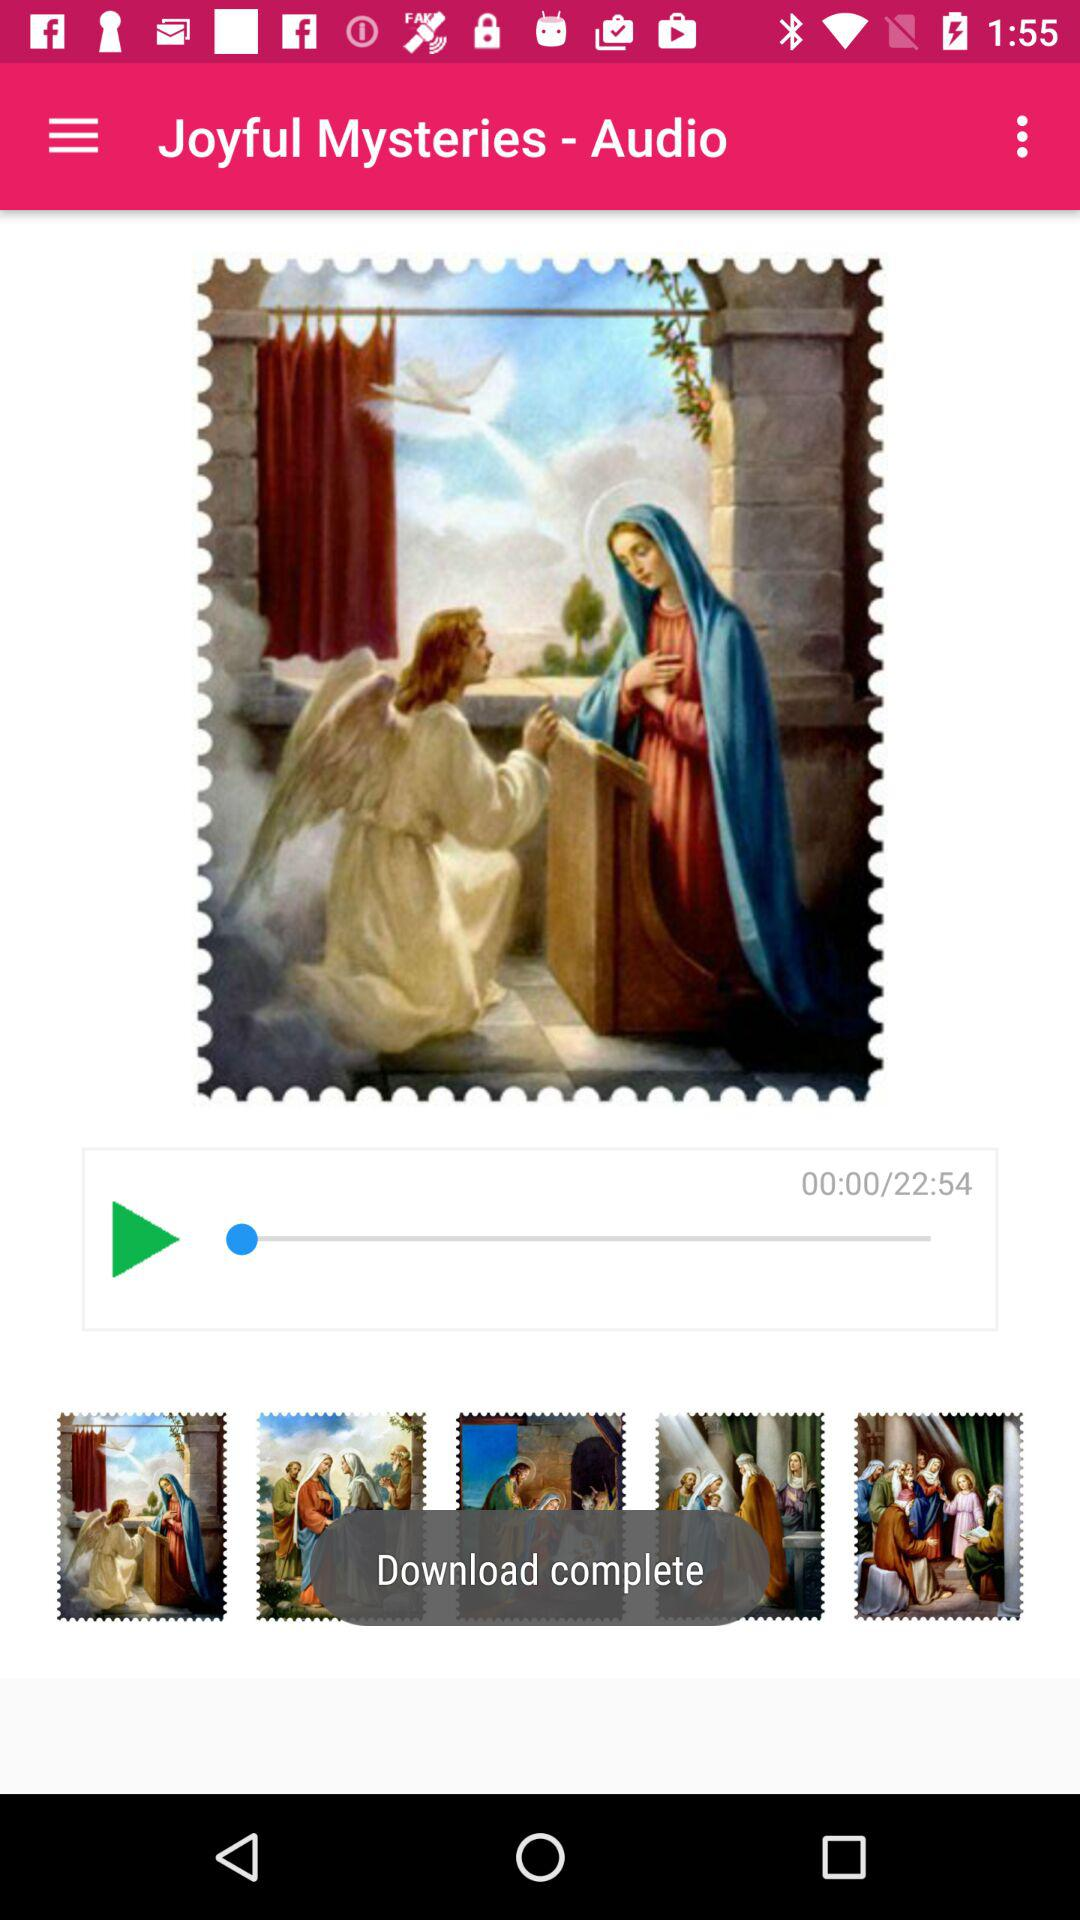What is the name of the audio? The name of the audio is "Joyful Mysteries". 